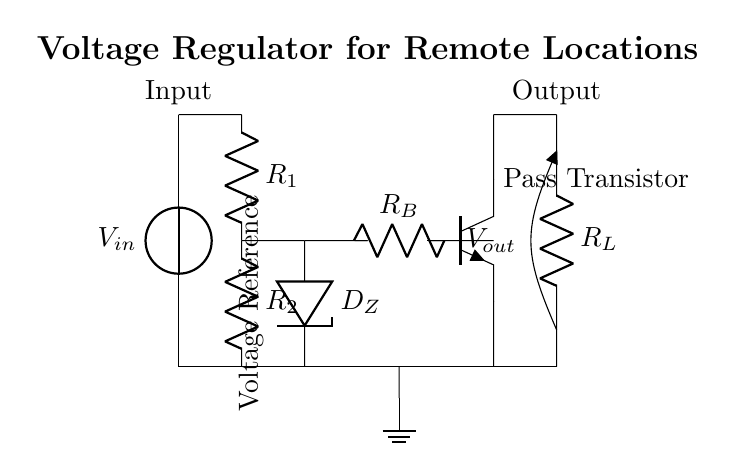What is the input voltage labeled as? The input voltage is labeled as V_in, which can be found near the voltage source in the diagram.
Answer: V_in What components are used in the voltage divider? The voltage divider consists of two resistors identified as R_1 and R_2, which are connected in series.
Answer: R_1 and R_2 What is the function of the Zener diode in this circuit? The Zener diode, labeled as D_Z, is used for voltage regulation by maintaining a stable output voltage across it.
Answer: Voltage regulation What type of transistor is used in this circuit? The transistor in this circuit is specified as a NPN transistor, indicated by the label Tnpn.
Answer: NPN How many resistors are there in the circuit? There are three resistors identified as R_1, R_2, and R_L in the circuit diagram.
Answer: Three What is the output voltage labeled as? The output voltage is identified as V_out, indicating the voltage across the load resistor R_L.
Answer: V_out Explain how the transistor's role assists the voltage regulation process. The NPN transistor serves as a pass transistor, controlling the current to the load based on the voltage across the Zener diode. When the voltage varies beyond a certain point, the transistor adjusts the output to maintain a steady voltage level, compensating for fluctuations. This feedback mechanism is crucial for effective voltage regulation.
Answer: Pass transistor control 